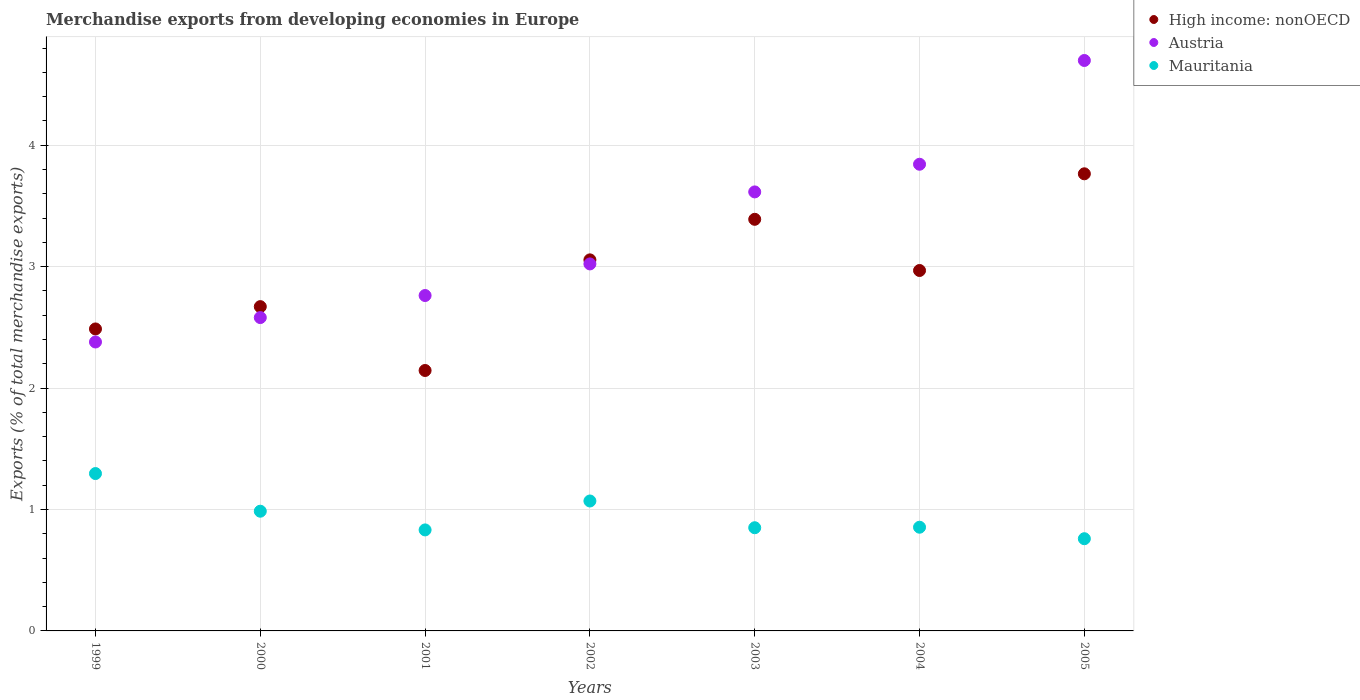What is the percentage of total merchandise exports in High income: nonOECD in 2001?
Give a very brief answer. 2.14. Across all years, what is the maximum percentage of total merchandise exports in Austria?
Your response must be concise. 4.7. Across all years, what is the minimum percentage of total merchandise exports in Austria?
Give a very brief answer. 2.38. In which year was the percentage of total merchandise exports in High income: nonOECD minimum?
Keep it short and to the point. 2001. What is the total percentage of total merchandise exports in Austria in the graph?
Provide a short and direct response. 22.9. What is the difference between the percentage of total merchandise exports in High income: nonOECD in 2003 and that in 2005?
Your answer should be compact. -0.37. What is the difference between the percentage of total merchandise exports in High income: nonOECD in 2000 and the percentage of total merchandise exports in Austria in 2005?
Offer a very short reply. -2.03. What is the average percentage of total merchandise exports in Mauritania per year?
Give a very brief answer. 0.95. In the year 2003, what is the difference between the percentage of total merchandise exports in Mauritania and percentage of total merchandise exports in High income: nonOECD?
Keep it short and to the point. -2.54. What is the ratio of the percentage of total merchandise exports in Mauritania in 2000 to that in 2005?
Give a very brief answer. 1.3. Is the percentage of total merchandise exports in Mauritania in 2001 less than that in 2003?
Provide a short and direct response. Yes. What is the difference between the highest and the second highest percentage of total merchandise exports in Mauritania?
Provide a short and direct response. 0.23. What is the difference between the highest and the lowest percentage of total merchandise exports in Mauritania?
Your answer should be very brief. 0.54. In how many years, is the percentage of total merchandise exports in High income: nonOECD greater than the average percentage of total merchandise exports in High income: nonOECD taken over all years?
Your answer should be compact. 4. Is the sum of the percentage of total merchandise exports in Austria in 1999 and 2002 greater than the maximum percentage of total merchandise exports in High income: nonOECD across all years?
Your answer should be compact. Yes. Is the percentage of total merchandise exports in Mauritania strictly greater than the percentage of total merchandise exports in High income: nonOECD over the years?
Your answer should be very brief. No. How many dotlines are there?
Keep it short and to the point. 3. Are the values on the major ticks of Y-axis written in scientific E-notation?
Make the answer very short. No. How many legend labels are there?
Give a very brief answer. 3. How are the legend labels stacked?
Your response must be concise. Vertical. What is the title of the graph?
Provide a short and direct response. Merchandise exports from developing economies in Europe. What is the label or title of the Y-axis?
Your answer should be very brief. Exports (% of total merchandise exports). What is the Exports (% of total merchandise exports) of High income: nonOECD in 1999?
Your answer should be very brief. 2.49. What is the Exports (% of total merchandise exports) of Austria in 1999?
Keep it short and to the point. 2.38. What is the Exports (% of total merchandise exports) of Mauritania in 1999?
Provide a succinct answer. 1.3. What is the Exports (% of total merchandise exports) in High income: nonOECD in 2000?
Your response must be concise. 2.67. What is the Exports (% of total merchandise exports) in Austria in 2000?
Give a very brief answer. 2.58. What is the Exports (% of total merchandise exports) in Mauritania in 2000?
Your response must be concise. 0.99. What is the Exports (% of total merchandise exports) in High income: nonOECD in 2001?
Give a very brief answer. 2.14. What is the Exports (% of total merchandise exports) in Austria in 2001?
Keep it short and to the point. 2.76. What is the Exports (% of total merchandise exports) in Mauritania in 2001?
Ensure brevity in your answer.  0.83. What is the Exports (% of total merchandise exports) of High income: nonOECD in 2002?
Your answer should be very brief. 3.06. What is the Exports (% of total merchandise exports) in Austria in 2002?
Keep it short and to the point. 3.02. What is the Exports (% of total merchandise exports) in Mauritania in 2002?
Offer a terse response. 1.07. What is the Exports (% of total merchandise exports) of High income: nonOECD in 2003?
Offer a very short reply. 3.39. What is the Exports (% of total merchandise exports) in Austria in 2003?
Provide a succinct answer. 3.62. What is the Exports (% of total merchandise exports) in Mauritania in 2003?
Your response must be concise. 0.85. What is the Exports (% of total merchandise exports) of High income: nonOECD in 2004?
Your answer should be compact. 2.97. What is the Exports (% of total merchandise exports) in Austria in 2004?
Give a very brief answer. 3.84. What is the Exports (% of total merchandise exports) of Mauritania in 2004?
Keep it short and to the point. 0.85. What is the Exports (% of total merchandise exports) in High income: nonOECD in 2005?
Make the answer very short. 3.76. What is the Exports (% of total merchandise exports) of Austria in 2005?
Make the answer very short. 4.7. What is the Exports (% of total merchandise exports) in Mauritania in 2005?
Provide a short and direct response. 0.76. Across all years, what is the maximum Exports (% of total merchandise exports) in High income: nonOECD?
Your answer should be compact. 3.76. Across all years, what is the maximum Exports (% of total merchandise exports) of Austria?
Give a very brief answer. 4.7. Across all years, what is the maximum Exports (% of total merchandise exports) of Mauritania?
Make the answer very short. 1.3. Across all years, what is the minimum Exports (% of total merchandise exports) of High income: nonOECD?
Ensure brevity in your answer.  2.14. Across all years, what is the minimum Exports (% of total merchandise exports) of Austria?
Make the answer very short. 2.38. Across all years, what is the minimum Exports (% of total merchandise exports) of Mauritania?
Give a very brief answer. 0.76. What is the total Exports (% of total merchandise exports) of High income: nonOECD in the graph?
Offer a terse response. 20.48. What is the total Exports (% of total merchandise exports) of Austria in the graph?
Provide a short and direct response. 22.9. What is the total Exports (% of total merchandise exports) of Mauritania in the graph?
Offer a terse response. 6.65. What is the difference between the Exports (% of total merchandise exports) of High income: nonOECD in 1999 and that in 2000?
Offer a terse response. -0.18. What is the difference between the Exports (% of total merchandise exports) in Austria in 1999 and that in 2000?
Your response must be concise. -0.2. What is the difference between the Exports (% of total merchandise exports) of Mauritania in 1999 and that in 2000?
Offer a terse response. 0.31. What is the difference between the Exports (% of total merchandise exports) in High income: nonOECD in 1999 and that in 2001?
Ensure brevity in your answer.  0.34. What is the difference between the Exports (% of total merchandise exports) in Austria in 1999 and that in 2001?
Offer a very short reply. -0.38. What is the difference between the Exports (% of total merchandise exports) of Mauritania in 1999 and that in 2001?
Make the answer very short. 0.46. What is the difference between the Exports (% of total merchandise exports) in High income: nonOECD in 1999 and that in 2002?
Your answer should be compact. -0.57. What is the difference between the Exports (% of total merchandise exports) in Austria in 1999 and that in 2002?
Keep it short and to the point. -0.64. What is the difference between the Exports (% of total merchandise exports) in Mauritania in 1999 and that in 2002?
Offer a very short reply. 0.23. What is the difference between the Exports (% of total merchandise exports) of High income: nonOECD in 1999 and that in 2003?
Your response must be concise. -0.9. What is the difference between the Exports (% of total merchandise exports) in Austria in 1999 and that in 2003?
Provide a short and direct response. -1.24. What is the difference between the Exports (% of total merchandise exports) of Mauritania in 1999 and that in 2003?
Give a very brief answer. 0.45. What is the difference between the Exports (% of total merchandise exports) of High income: nonOECD in 1999 and that in 2004?
Offer a very short reply. -0.48. What is the difference between the Exports (% of total merchandise exports) of Austria in 1999 and that in 2004?
Your answer should be very brief. -1.46. What is the difference between the Exports (% of total merchandise exports) of Mauritania in 1999 and that in 2004?
Give a very brief answer. 0.44. What is the difference between the Exports (% of total merchandise exports) in High income: nonOECD in 1999 and that in 2005?
Offer a terse response. -1.28. What is the difference between the Exports (% of total merchandise exports) in Austria in 1999 and that in 2005?
Offer a very short reply. -2.32. What is the difference between the Exports (% of total merchandise exports) in Mauritania in 1999 and that in 2005?
Your response must be concise. 0.54. What is the difference between the Exports (% of total merchandise exports) in High income: nonOECD in 2000 and that in 2001?
Your answer should be very brief. 0.53. What is the difference between the Exports (% of total merchandise exports) of Austria in 2000 and that in 2001?
Your answer should be very brief. -0.18. What is the difference between the Exports (% of total merchandise exports) in Mauritania in 2000 and that in 2001?
Keep it short and to the point. 0.15. What is the difference between the Exports (% of total merchandise exports) of High income: nonOECD in 2000 and that in 2002?
Your answer should be compact. -0.39. What is the difference between the Exports (% of total merchandise exports) of Austria in 2000 and that in 2002?
Provide a short and direct response. -0.44. What is the difference between the Exports (% of total merchandise exports) in Mauritania in 2000 and that in 2002?
Your answer should be compact. -0.08. What is the difference between the Exports (% of total merchandise exports) of High income: nonOECD in 2000 and that in 2003?
Your answer should be compact. -0.72. What is the difference between the Exports (% of total merchandise exports) of Austria in 2000 and that in 2003?
Your response must be concise. -1.03. What is the difference between the Exports (% of total merchandise exports) in Mauritania in 2000 and that in 2003?
Your response must be concise. 0.14. What is the difference between the Exports (% of total merchandise exports) of High income: nonOECD in 2000 and that in 2004?
Offer a very short reply. -0.3. What is the difference between the Exports (% of total merchandise exports) of Austria in 2000 and that in 2004?
Offer a very short reply. -1.26. What is the difference between the Exports (% of total merchandise exports) in Mauritania in 2000 and that in 2004?
Your answer should be very brief. 0.13. What is the difference between the Exports (% of total merchandise exports) in High income: nonOECD in 2000 and that in 2005?
Make the answer very short. -1.09. What is the difference between the Exports (% of total merchandise exports) in Austria in 2000 and that in 2005?
Give a very brief answer. -2.12. What is the difference between the Exports (% of total merchandise exports) in Mauritania in 2000 and that in 2005?
Your answer should be compact. 0.23. What is the difference between the Exports (% of total merchandise exports) of High income: nonOECD in 2001 and that in 2002?
Provide a succinct answer. -0.91. What is the difference between the Exports (% of total merchandise exports) in Austria in 2001 and that in 2002?
Your response must be concise. -0.26. What is the difference between the Exports (% of total merchandise exports) of Mauritania in 2001 and that in 2002?
Ensure brevity in your answer.  -0.24. What is the difference between the Exports (% of total merchandise exports) in High income: nonOECD in 2001 and that in 2003?
Your response must be concise. -1.24. What is the difference between the Exports (% of total merchandise exports) of Austria in 2001 and that in 2003?
Provide a succinct answer. -0.85. What is the difference between the Exports (% of total merchandise exports) in Mauritania in 2001 and that in 2003?
Make the answer very short. -0.02. What is the difference between the Exports (% of total merchandise exports) in High income: nonOECD in 2001 and that in 2004?
Keep it short and to the point. -0.82. What is the difference between the Exports (% of total merchandise exports) of Austria in 2001 and that in 2004?
Your response must be concise. -1.08. What is the difference between the Exports (% of total merchandise exports) in Mauritania in 2001 and that in 2004?
Provide a short and direct response. -0.02. What is the difference between the Exports (% of total merchandise exports) in High income: nonOECD in 2001 and that in 2005?
Offer a terse response. -1.62. What is the difference between the Exports (% of total merchandise exports) of Austria in 2001 and that in 2005?
Keep it short and to the point. -1.94. What is the difference between the Exports (% of total merchandise exports) in Mauritania in 2001 and that in 2005?
Make the answer very short. 0.07. What is the difference between the Exports (% of total merchandise exports) in High income: nonOECD in 2002 and that in 2003?
Offer a terse response. -0.33. What is the difference between the Exports (% of total merchandise exports) of Austria in 2002 and that in 2003?
Your answer should be very brief. -0.59. What is the difference between the Exports (% of total merchandise exports) in Mauritania in 2002 and that in 2003?
Offer a very short reply. 0.22. What is the difference between the Exports (% of total merchandise exports) of High income: nonOECD in 2002 and that in 2004?
Keep it short and to the point. 0.09. What is the difference between the Exports (% of total merchandise exports) of Austria in 2002 and that in 2004?
Your answer should be compact. -0.82. What is the difference between the Exports (% of total merchandise exports) of Mauritania in 2002 and that in 2004?
Offer a terse response. 0.22. What is the difference between the Exports (% of total merchandise exports) of High income: nonOECD in 2002 and that in 2005?
Keep it short and to the point. -0.71. What is the difference between the Exports (% of total merchandise exports) in Austria in 2002 and that in 2005?
Your answer should be compact. -1.68. What is the difference between the Exports (% of total merchandise exports) in Mauritania in 2002 and that in 2005?
Your answer should be very brief. 0.31. What is the difference between the Exports (% of total merchandise exports) of High income: nonOECD in 2003 and that in 2004?
Your response must be concise. 0.42. What is the difference between the Exports (% of total merchandise exports) of Austria in 2003 and that in 2004?
Provide a short and direct response. -0.23. What is the difference between the Exports (% of total merchandise exports) of Mauritania in 2003 and that in 2004?
Provide a short and direct response. -0. What is the difference between the Exports (% of total merchandise exports) in High income: nonOECD in 2003 and that in 2005?
Make the answer very short. -0.37. What is the difference between the Exports (% of total merchandise exports) of Austria in 2003 and that in 2005?
Your answer should be compact. -1.08. What is the difference between the Exports (% of total merchandise exports) of Mauritania in 2003 and that in 2005?
Your answer should be compact. 0.09. What is the difference between the Exports (% of total merchandise exports) of High income: nonOECD in 2004 and that in 2005?
Offer a very short reply. -0.8. What is the difference between the Exports (% of total merchandise exports) in Austria in 2004 and that in 2005?
Give a very brief answer. -0.85. What is the difference between the Exports (% of total merchandise exports) in Mauritania in 2004 and that in 2005?
Offer a terse response. 0.09. What is the difference between the Exports (% of total merchandise exports) of High income: nonOECD in 1999 and the Exports (% of total merchandise exports) of Austria in 2000?
Provide a short and direct response. -0.09. What is the difference between the Exports (% of total merchandise exports) in High income: nonOECD in 1999 and the Exports (% of total merchandise exports) in Mauritania in 2000?
Give a very brief answer. 1.5. What is the difference between the Exports (% of total merchandise exports) of Austria in 1999 and the Exports (% of total merchandise exports) of Mauritania in 2000?
Provide a short and direct response. 1.39. What is the difference between the Exports (% of total merchandise exports) in High income: nonOECD in 1999 and the Exports (% of total merchandise exports) in Austria in 2001?
Provide a short and direct response. -0.28. What is the difference between the Exports (% of total merchandise exports) in High income: nonOECD in 1999 and the Exports (% of total merchandise exports) in Mauritania in 2001?
Your response must be concise. 1.65. What is the difference between the Exports (% of total merchandise exports) of Austria in 1999 and the Exports (% of total merchandise exports) of Mauritania in 2001?
Make the answer very short. 1.55. What is the difference between the Exports (% of total merchandise exports) in High income: nonOECD in 1999 and the Exports (% of total merchandise exports) in Austria in 2002?
Offer a terse response. -0.54. What is the difference between the Exports (% of total merchandise exports) of High income: nonOECD in 1999 and the Exports (% of total merchandise exports) of Mauritania in 2002?
Provide a succinct answer. 1.42. What is the difference between the Exports (% of total merchandise exports) of Austria in 1999 and the Exports (% of total merchandise exports) of Mauritania in 2002?
Make the answer very short. 1.31. What is the difference between the Exports (% of total merchandise exports) of High income: nonOECD in 1999 and the Exports (% of total merchandise exports) of Austria in 2003?
Your answer should be compact. -1.13. What is the difference between the Exports (% of total merchandise exports) in High income: nonOECD in 1999 and the Exports (% of total merchandise exports) in Mauritania in 2003?
Offer a very short reply. 1.64. What is the difference between the Exports (% of total merchandise exports) of Austria in 1999 and the Exports (% of total merchandise exports) of Mauritania in 2003?
Provide a short and direct response. 1.53. What is the difference between the Exports (% of total merchandise exports) of High income: nonOECD in 1999 and the Exports (% of total merchandise exports) of Austria in 2004?
Keep it short and to the point. -1.36. What is the difference between the Exports (% of total merchandise exports) in High income: nonOECD in 1999 and the Exports (% of total merchandise exports) in Mauritania in 2004?
Offer a terse response. 1.63. What is the difference between the Exports (% of total merchandise exports) in Austria in 1999 and the Exports (% of total merchandise exports) in Mauritania in 2004?
Ensure brevity in your answer.  1.53. What is the difference between the Exports (% of total merchandise exports) in High income: nonOECD in 1999 and the Exports (% of total merchandise exports) in Austria in 2005?
Provide a short and direct response. -2.21. What is the difference between the Exports (% of total merchandise exports) of High income: nonOECD in 1999 and the Exports (% of total merchandise exports) of Mauritania in 2005?
Offer a terse response. 1.73. What is the difference between the Exports (% of total merchandise exports) of Austria in 1999 and the Exports (% of total merchandise exports) of Mauritania in 2005?
Give a very brief answer. 1.62. What is the difference between the Exports (% of total merchandise exports) of High income: nonOECD in 2000 and the Exports (% of total merchandise exports) of Austria in 2001?
Make the answer very short. -0.09. What is the difference between the Exports (% of total merchandise exports) of High income: nonOECD in 2000 and the Exports (% of total merchandise exports) of Mauritania in 2001?
Keep it short and to the point. 1.84. What is the difference between the Exports (% of total merchandise exports) of Austria in 2000 and the Exports (% of total merchandise exports) of Mauritania in 2001?
Make the answer very short. 1.75. What is the difference between the Exports (% of total merchandise exports) of High income: nonOECD in 2000 and the Exports (% of total merchandise exports) of Austria in 2002?
Offer a terse response. -0.35. What is the difference between the Exports (% of total merchandise exports) in High income: nonOECD in 2000 and the Exports (% of total merchandise exports) in Mauritania in 2002?
Ensure brevity in your answer.  1.6. What is the difference between the Exports (% of total merchandise exports) of Austria in 2000 and the Exports (% of total merchandise exports) of Mauritania in 2002?
Offer a very short reply. 1.51. What is the difference between the Exports (% of total merchandise exports) in High income: nonOECD in 2000 and the Exports (% of total merchandise exports) in Austria in 2003?
Give a very brief answer. -0.94. What is the difference between the Exports (% of total merchandise exports) of High income: nonOECD in 2000 and the Exports (% of total merchandise exports) of Mauritania in 2003?
Make the answer very short. 1.82. What is the difference between the Exports (% of total merchandise exports) in Austria in 2000 and the Exports (% of total merchandise exports) in Mauritania in 2003?
Your answer should be very brief. 1.73. What is the difference between the Exports (% of total merchandise exports) of High income: nonOECD in 2000 and the Exports (% of total merchandise exports) of Austria in 2004?
Give a very brief answer. -1.17. What is the difference between the Exports (% of total merchandise exports) of High income: nonOECD in 2000 and the Exports (% of total merchandise exports) of Mauritania in 2004?
Ensure brevity in your answer.  1.82. What is the difference between the Exports (% of total merchandise exports) of Austria in 2000 and the Exports (% of total merchandise exports) of Mauritania in 2004?
Provide a succinct answer. 1.73. What is the difference between the Exports (% of total merchandise exports) of High income: nonOECD in 2000 and the Exports (% of total merchandise exports) of Austria in 2005?
Offer a very short reply. -2.03. What is the difference between the Exports (% of total merchandise exports) of High income: nonOECD in 2000 and the Exports (% of total merchandise exports) of Mauritania in 2005?
Your answer should be compact. 1.91. What is the difference between the Exports (% of total merchandise exports) in Austria in 2000 and the Exports (% of total merchandise exports) in Mauritania in 2005?
Offer a very short reply. 1.82. What is the difference between the Exports (% of total merchandise exports) of High income: nonOECD in 2001 and the Exports (% of total merchandise exports) of Austria in 2002?
Your response must be concise. -0.88. What is the difference between the Exports (% of total merchandise exports) of High income: nonOECD in 2001 and the Exports (% of total merchandise exports) of Mauritania in 2002?
Your answer should be very brief. 1.07. What is the difference between the Exports (% of total merchandise exports) in Austria in 2001 and the Exports (% of total merchandise exports) in Mauritania in 2002?
Give a very brief answer. 1.69. What is the difference between the Exports (% of total merchandise exports) of High income: nonOECD in 2001 and the Exports (% of total merchandise exports) of Austria in 2003?
Your answer should be very brief. -1.47. What is the difference between the Exports (% of total merchandise exports) in High income: nonOECD in 2001 and the Exports (% of total merchandise exports) in Mauritania in 2003?
Offer a terse response. 1.29. What is the difference between the Exports (% of total merchandise exports) of Austria in 2001 and the Exports (% of total merchandise exports) of Mauritania in 2003?
Keep it short and to the point. 1.91. What is the difference between the Exports (% of total merchandise exports) in High income: nonOECD in 2001 and the Exports (% of total merchandise exports) in Austria in 2004?
Ensure brevity in your answer.  -1.7. What is the difference between the Exports (% of total merchandise exports) in High income: nonOECD in 2001 and the Exports (% of total merchandise exports) in Mauritania in 2004?
Provide a succinct answer. 1.29. What is the difference between the Exports (% of total merchandise exports) of Austria in 2001 and the Exports (% of total merchandise exports) of Mauritania in 2004?
Your answer should be very brief. 1.91. What is the difference between the Exports (% of total merchandise exports) in High income: nonOECD in 2001 and the Exports (% of total merchandise exports) in Austria in 2005?
Ensure brevity in your answer.  -2.55. What is the difference between the Exports (% of total merchandise exports) of High income: nonOECD in 2001 and the Exports (% of total merchandise exports) of Mauritania in 2005?
Provide a succinct answer. 1.39. What is the difference between the Exports (% of total merchandise exports) in Austria in 2001 and the Exports (% of total merchandise exports) in Mauritania in 2005?
Your response must be concise. 2. What is the difference between the Exports (% of total merchandise exports) in High income: nonOECD in 2002 and the Exports (% of total merchandise exports) in Austria in 2003?
Provide a succinct answer. -0.56. What is the difference between the Exports (% of total merchandise exports) of High income: nonOECD in 2002 and the Exports (% of total merchandise exports) of Mauritania in 2003?
Provide a short and direct response. 2.21. What is the difference between the Exports (% of total merchandise exports) of Austria in 2002 and the Exports (% of total merchandise exports) of Mauritania in 2003?
Provide a short and direct response. 2.17. What is the difference between the Exports (% of total merchandise exports) of High income: nonOECD in 2002 and the Exports (% of total merchandise exports) of Austria in 2004?
Your response must be concise. -0.79. What is the difference between the Exports (% of total merchandise exports) in High income: nonOECD in 2002 and the Exports (% of total merchandise exports) in Mauritania in 2004?
Your answer should be compact. 2.2. What is the difference between the Exports (% of total merchandise exports) of Austria in 2002 and the Exports (% of total merchandise exports) of Mauritania in 2004?
Give a very brief answer. 2.17. What is the difference between the Exports (% of total merchandise exports) of High income: nonOECD in 2002 and the Exports (% of total merchandise exports) of Austria in 2005?
Provide a succinct answer. -1.64. What is the difference between the Exports (% of total merchandise exports) in High income: nonOECD in 2002 and the Exports (% of total merchandise exports) in Mauritania in 2005?
Ensure brevity in your answer.  2.3. What is the difference between the Exports (% of total merchandise exports) of Austria in 2002 and the Exports (% of total merchandise exports) of Mauritania in 2005?
Your response must be concise. 2.26. What is the difference between the Exports (% of total merchandise exports) of High income: nonOECD in 2003 and the Exports (% of total merchandise exports) of Austria in 2004?
Your answer should be compact. -0.45. What is the difference between the Exports (% of total merchandise exports) in High income: nonOECD in 2003 and the Exports (% of total merchandise exports) in Mauritania in 2004?
Keep it short and to the point. 2.54. What is the difference between the Exports (% of total merchandise exports) in Austria in 2003 and the Exports (% of total merchandise exports) in Mauritania in 2004?
Offer a terse response. 2.76. What is the difference between the Exports (% of total merchandise exports) of High income: nonOECD in 2003 and the Exports (% of total merchandise exports) of Austria in 2005?
Offer a terse response. -1.31. What is the difference between the Exports (% of total merchandise exports) of High income: nonOECD in 2003 and the Exports (% of total merchandise exports) of Mauritania in 2005?
Ensure brevity in your answer.  2.63. What is the difference between the Exports (% of total merchandise exports) of Austria in 2003 and the Exports (% of total merchandise exports) of Mauritania in 2005?
Offer a terse response. 2.86. What is the difference between the Exports (% of total merchandise exports) in High income: nonOECD in 2004 and the Exports (% of total merchandise exports) in Austria in 2005?
Offer a terse response. -1.73. What is the difference between the Exports (% of total merchandise exports) of High income: nonOECD in 2004 and the Exports (% of total merchandise exports) of Mauritania in 2005?
Offer a very short reply. 2.21. What is the difference between the Exports (% of total merchandise exports) in Austria in 2004 and the Exports (% of total merchandise exports) in Mauritania in 2005?
Your answer should be very brief. 3.08. What is the average Exports (% of total merchandise exports) in High income: nonOECD per year?
Provide a succinct answer. 2.93. What is the average Exports (% of total merchandise exports) in Austria per year?
Give a very brief answer. 3.27. What is the average Exports (% of total merchandise exports) of Mauritania per year?
Your answer should be very brief. 0.95. In the year 1999, what is the difference between the Exports (% of total merchandise exports) of High income: nonOECD and Exports (% of total merchandise exports) of Austria?
Ensure brevity in your answer.  0.11. In the year 1999, what is the difference between the Exports (% of total merchandise exports) in High income: nonOECD and Exports (% of total merchandise exports) in Mauritania?
Your response must be concise. 1.19. In the year 1999, what is the difference between the Exports (% of total merchandise exports) of Austria and Exports (% of total merchandise exports) of Mauritania?
Make the answer very short. 1.08. In the year 2000, what is the difference between the Exports (% of total merchandise exports) of High income: nonOECD and Exports (% of total merchandise exports) of Austria?
Provide a succinct answer. 0.09. In the year 2000, what is the difference between the Exports (% of total merchandise exports) of High income: nonOECD and Exports (% of total merchandise exports) of Mauritania?
Your answer should be very brief. 1.68. In the year 2000, what is the difference between the Exports (% of total merchandise exports) in Austria and Exports (% of total merchandise exports) in Mauritania?
Offer a terse response. 1.59. In the year 2001, what is the difference between the Exports (% of total merchandise exports) of High income: nonOECD and Exports (% of total merchandise exports) of Austria?
Provide a short and direct response. -0.62. In the year 2001, what is the difference between the Exports (% of total merchandise exports) in High income: nonOECD and Exports (% of total merchandise exports) in Mauritania?
Ensure brevity in your answer.  1.31. In the year 2001, what is the difference between the Exports (% of total merchandise exports) in Austria and Exports (% of total merchandise exports) in Mauritania?
Give a very brief answer. 1.93. In the year 2002, what is the difference between the Exports (% of total merchandise exports) of High income: nonOECD and Exports (% of total merchandise exports) of Austria?
Your response must be concise. 0.03. In the year 2002, what is the difference between the Exports (% of total merchandise exports) of High income: nonOECD and Exports (% of total merchandise exports) of Mauritania?
Offer a terse response. 1.99. In the year 2002, what is the difference between the Exports (% of total merchandise exports) in Austria and Exports (% of total merchandise exports) in Mauritania?
Your response must be concise. 1.95. In the year 2003, what is the difference between the Exports (% of total merchandise exports) of High income: nonOECD and Exports (% of total merchandise exports) of Austria?
Make the answer very short. -0.23. In the year 2003, what is the difference between the Exports (% of total merchandise exports) of High income: nonOECD and Exports (% of total merchandise exports) of Mauritania?
Ensure brevity in your answer.  2.54. In the year 2003, what is the difference between the Exports (% of total merchandise exports) in Austria and Exports (% of total merchandise exports) in Mauritania?
Your answer should be very brief. 2.77. In the year 2004, what is the difference between the Exports (% of total merchandise exports) in High income: nonOECD and Exports (% of total merchandise exports) in Austria?
Your answer should be compact. -0.87. In the year 2004, what is the difference between the Exports (% of total merchandise exports) of High income: nonOECD and Exports (% of total merchandise exports) of Mauritania?
Keep it short and to the point. 2.11. In the year 2004, what is the difference between the Exports (% of total merchandise exports) in Austria and Exports (% of total merchandise exports) in Mauritania?
Keep it short and to the point. 2.99. In the year 2005, what is the difference between the Exports (% of total merchandise exports) in High income: nonOECD and Exports (% of total merchandise exports) in Austria?
Your answer should be very brief. -0.93. In the year 2005, what is the difference between the Exports (% of total merchandise exports) in High income: nonOECD and Exports (% of total merchandise exports) in Mauritania?
Your response must be concise. 3. In the year 2005, what is the difference between the Exports (% of total merchandise exports) in Austria and Exports (% of total merchandise exports) in Mauritania?
Ensure brevity in your answer.  3.94. What is the ratio of the Exports (% of total merchandise exports) of High income: nonOECD in 1999 to that in 2000?
Your answer should be compact. 0.93. What is the ratio of the Exports (% of total merchandise exports) of Austria in 1999 to that in 2000?
Keep it short and to the point. 0.92. What is the ratio of the Exports (% of total merchandise exports) of Mauritania in 1999 to that in 2000?
Provide a short and direct response. 1.31. What is the ratio of the Exports (% of total merchandise exports) of High income: nonOECD in 1999 to that in 2001?
Make the answer very short. 1.16. What is the ratio of the Exports (% of total merchandise exports) in Austria in 1999 to that in 2001?
Your answer should be very brief. 0.86. What is the ratio of the Exports (% of total merchandise exports) in Mauritania in 1999 to that in 2001?
Make the answer very short. 1.56. What is the ratio of the Exports (% of total merchandise exports) of High income: nonOECD in 1999 to that in 2002?
Your answer should be compact. 0.81. What is the ratio of the Exports (% of total merchandise exports) of Austria in 1999 to that in 2002?
Offer a very short reply. 0.79. What is the ratio of the Exports (% of total merchandise exports) in Mauritania in 1999 to that in 2002?
Make the answer very short. 1.21. What is the ratio of the Exports (% of total merchandise exports) in High income: nonOECD in 1999 to that in 2003?
Ensure brevity in your answer.  0.73. What is the ratio of the Exports (% of total merchandise exports) of Austria in 1999 to that in 2003?
Your answer should be compact. 0.66. What is the ratio of the Exports (% of total merchandise exports) in Mauritania in 1999 to that in 2003?
Provide a succinct answer. 1.53. What is the ratio of the Exports (% of total merchandise exports) of High income: nonOECD in 1999 to that in 2004?
Your answer should be very brief. 0.84. What is the ratio of the Exports (% of total merchandise exports) of Austria in 1999 to that in 2004?
Ensure brevity in your answer.  0.62. What is the ratio of the Exports (% of total merchandise exports) in Mauritania in 1999 to that in 2004?
Give a very brief answer. 1.52. What is the ratio of the Exports (% of total merchandise exports) in High income: nonOECD in 1999 to that in 2005?
Provide a succinct answer. 0.66. What is the ratio of the Exports (% of total merchandise exports) of Austria in 1999 to that in 2005?
Provide a short and direct response. 0.51. What is the ratio of the Exports (% of total merchandise exports) of Mauritania in 1999 to that in 2005?
Provide a short and direct response. 1.71. What is the ratio of the Exports (% of total merchandise exports) of High income: nonOECD in 2000 to that in 2001?
Your response must be concise. 1.25. What is the ratio of the Exports (% of total merchandise exports) of Austria in 2000 to that in 2001?
Provide a succinct answer. 0.93. What is the ratio of the Exports (% of total merchandise exports) of Mauritania in 2000 to that in 2001?
Provide a succinct answer. 1.19. What is the ratio of the Exports (% of total merchandise exports) of High income: nonOECD in 2000 to that in 2002?
Make the answer very short. 0.87. What is the ratio of the Exports (% of total merchandise exports) in Austria in 2000 to that in 2002?
Your answer should be very brief. 0.85. What is the ratio of the Exports (% of total merchandise exports) in Mauritania in 2000 to that in 2002?
Ensure brevity in your answer.  0.92. What is the ratio of the Exports (% of total merchandise exports) of High income: nonOECD in 2000 to that in 2003?
Your response must be concise. 0.79. What is the ratio of the Exports (% of total merchandise exports) of Austria in 2000 to that in 2003?
Make the answer very short. 0.71. What is the ratio of the Exports (% of total merchandise exports) in Mauritania in 2000 to that in 2003?
Ensure brevity in your answer.  1.16. What is the ratio of the Exports (% of total merchandise exports) of High income: nonOECD in 2000 to that in 2004?
Give a very brief answer. 0.9. What is the ratio of the Exports (% of total merchandise exports) in Austria in 2000 to that in 2004?
Make the answer very short. 0.67. What is the ratio of the Exports (% of total merchandise exports) of Mauritania in 2000 to that in 2004?
Your answer should be compact. 1.15. What is the ratio of the Exports (% of total merchandise exports) of High income: nonOECD in 2000 to that in 2005?
Your answer should be very brief. 0.71. What is the ratio of the Exports (% of total merchandise exports) in Austria in 2000 to that in 2005?
Offer a very short reply. 0.55. What is the ratio of the Exports (% of total merchandise exports) of Mauritania in 2000 to that in 2005?
Your answer should be compact. 1.3. What is the ratio of the Exports (% of total merchandise exports) in High income: nonOECD in 2001 to that in 2002?
Ensure brevity in your answer.  0.7. What is the ratio of the Exports (% of total merchandise exports) of Austria in 2001 to that in 2002?
Your answer should be very brief. 0.91. What is the ratio of the Exports (% of total merchandise exports) of Mauritania in 2001 to that in 2002?
Provide a succinct answer. 0.78. What is the ratio of the Exports (% of total merchandise exports) in High income: nonOECD in 2001 to that in 2003?
Your answer should be very brief. 0.63. What is the ratio of the Exports (% of total merchandise exports) of Austria in 2001 to that in 2003?
Make the answer very short. 0.76. What is the ratio of the Exports (% of total merchandise exports) of Mauritania in 2001 to that in 2003?
Offer a very short reply. 0.98. What is the ratio of the Exports (% of total merchandise exports) in High income: nonOECD in 2001 to that in 2004?
Keep it short and to the point. 0.72. What is the ratio of the Exports (% of total merchandise exports) of Austria in 2001 to that in 2004?
Give a very brief answer. 0.72. What is the ratio of the Exports (% of total merchandise exports) in Mauritania in 2001 to that in 2004?
Ensure brevity in your answer.  0.97. What is the ratio of the Exports (% of total merchandise exports) in High income: nonOECD in 2001 to that in 2005?
Make the answer very short. 0.57. What is the ratio of the Exports (% of total merchandise exports) in Austria in 2001 to that in 2005?
Your answer should be compact. 0.59. What is the ratio of the Exports (% of total merchandise exports) in Mauritania in 2001 to that in 2005?
Provide a succinct answer. 1.1. What is the ratio of the Exports (% of total merchandise exports) in High income: nonOECD in 2002 to that in 2003?
Ensure brevity in your answer.  0.9. What is the ratio of the Exports (% of total merchandise exports) in Austria in 2002 to that in 2003?
Offer a terse response. 0.84. What is the ratio of the Exports (% of total merchandise exports) in Mauritania in 2002 to that in 2003?
Your answer should be very brief. 1.26. What is the ratio of the Exports (% of total merchandise exports) of High income: nonOECD in 2002 to that in 2004?
Make the answer very short. 1.03. What is the ratio of the Exports (% of total merchandise exports) in Austria in 2002 to that in 2004?
Keep it short and to the point. 0.79. What is the ratio of the Exports (% of total merchandise exports) of Mauritania in 2002 to that in 2004?
Provide a succinct answer. 1.25. What is the ratio of the Exports (% of total merchandise exports) in High income: nonOECD in 2002 to that in 2005?
Provide a succinct answer. 0.81. What is the ratio of the Exports (% of total merchandise exports) in Austria in 2002 to that in 2005?
Offer a terse response. 0.64. What is the ratio of the Exports (% of total merchandise exports) in Mauritania in 2002 to that in 2005?
Offer a terse response. 1.41. What is the ratio of the Exports (% of total merchandise exports) of High income: nonOECD in 2003 to that in 2004?
Give a very brief answer. 1.14. What is the ratio of the Exports (% of total merchandise exports) in Austria in 2003 to that in 2004?
Provide a short and direct response. 0.94. What is the ratio of the Exports (% of total merchandise exports) in High income: nonOECD in 2003 to that in 2005?
Give a very brief answer. 0.9. What is the ratio of the Exports (% of total merchandise exports) of Austria in 2003 to that in 2005?
Make the answer very short. 0.77. What is the ratio of the Exports (% of total merchandise exports) of Mauritania in 2003 to that in 2005?
Your response must be concise. 1.12. What is the ratio of the Exports (% of total merchandise exports) of High income: nonOECD in 2004 to that in 2005?
Provide a short and direct response. 0.79. What is the ratio of the Exports (% of total merchandise exports) of Austria in 2004 to that in 2005?
Provide a succinct answer. 0.82. What is the ratio of the Exports (% of total merchandise exports) of Mauritania in 2004 to that in 2005?
Make the answer very short. 1.12. What is the difference between the highest and the second highest Exports (% of total merchandise exports) in High income: nonOECD?
Keep it short and to the point. 0.37. What is the difference between the highest and the second highest Exports (% of total merchandise exports) in Austria?
Make the answer very short. 0.85. What is the difference between the highest and the second highest Exports (% of total merchandise exports) in Mauritania?
Provide a short and direct response. 0.23. What is the difference between the highest and the lowest Exports (% of total merchandise exports) of High income: nonOECD?
Make the answer very short. 1.62. What is the difference between the highest and the lowest Exports (% of total merchandise exports) in Austria?
Ensure brevity in your answer.  2.32. What is the difference between the highest and the lowest Exports (% of total merchandise exports) of Mauritania?
Your answer should be very brief. 0.54. 